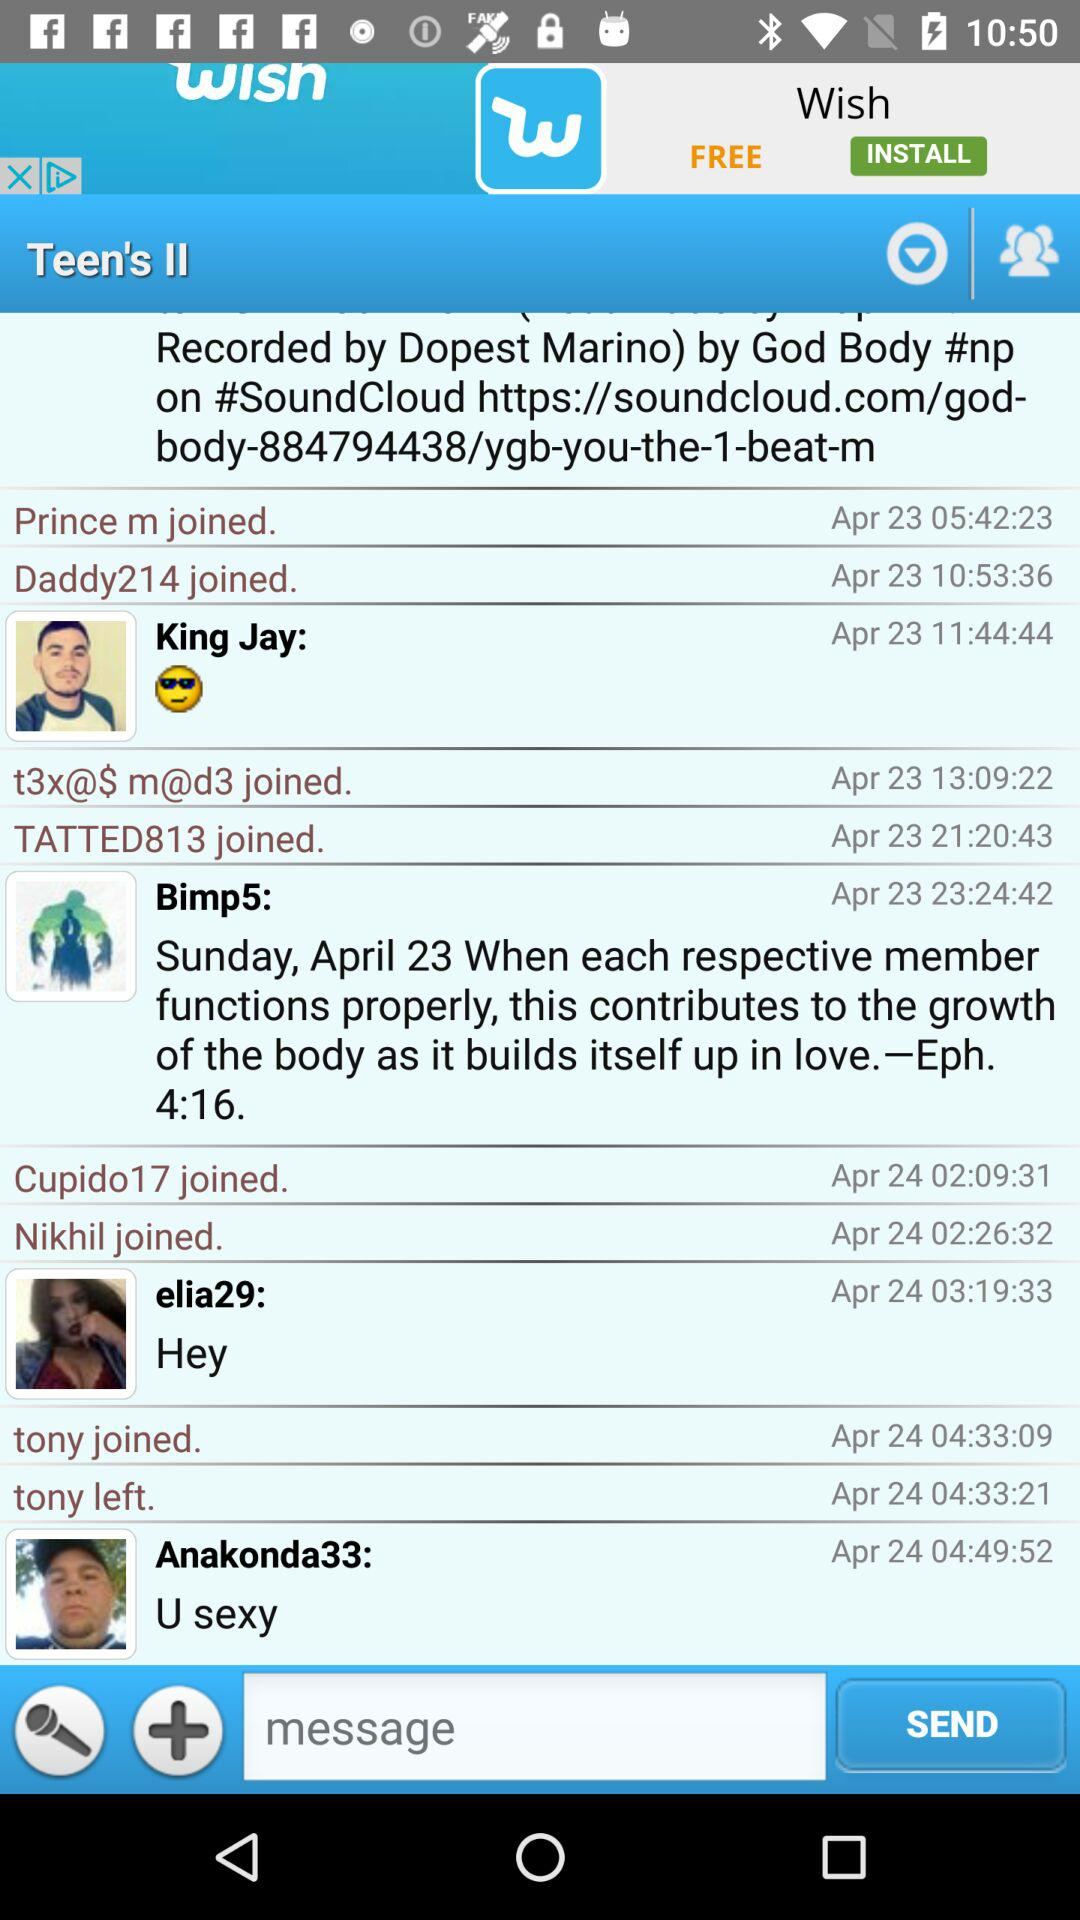At what time did Tony leave? Tony leaves at 04:33:21. 